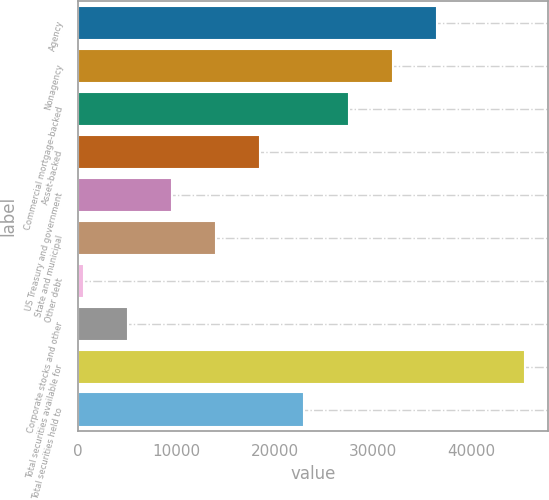Convert chart. <chart><loc_0><loc_0><loc_500><loc_500><bar_chart><fcel>Agency<fcel>Nonagency<fcel>Commercial mortgage-backed<fcel>Asset-backed<fcel>US Treasury and government<fcel>State and municipal<fcel>Other debt<fcel>Corporate stocks and other<fcel>Total securities available for<fcel>Total securities held to<nl><fcel>36532.6<fcel>32036.4<fcel>27540.2<fcel>18547.8<fcel>9555.4<fcel>14051.6<fcel>563<fcel>5059.2<fcel>45525<fcel>23044<nl></chart> 